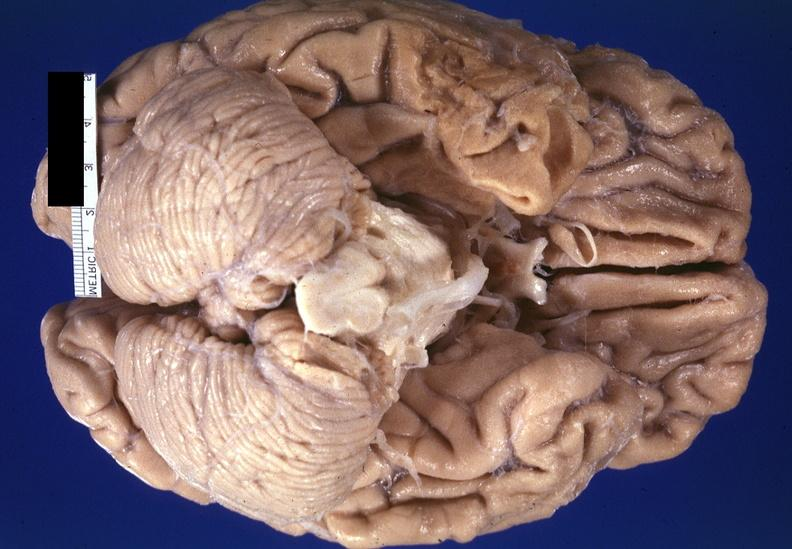what does this image show?
Answer the question using a single word or phrase. Brain 